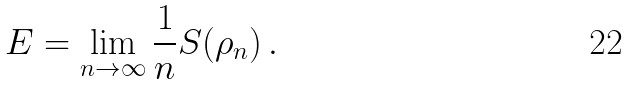<formula> <loc_0><loc_0><loc_500><loc_500>E = \lim _ { n \rightarrow \infty } \frac { 1 } { n } S ( \rho _ { n } ) \, .</formula> 